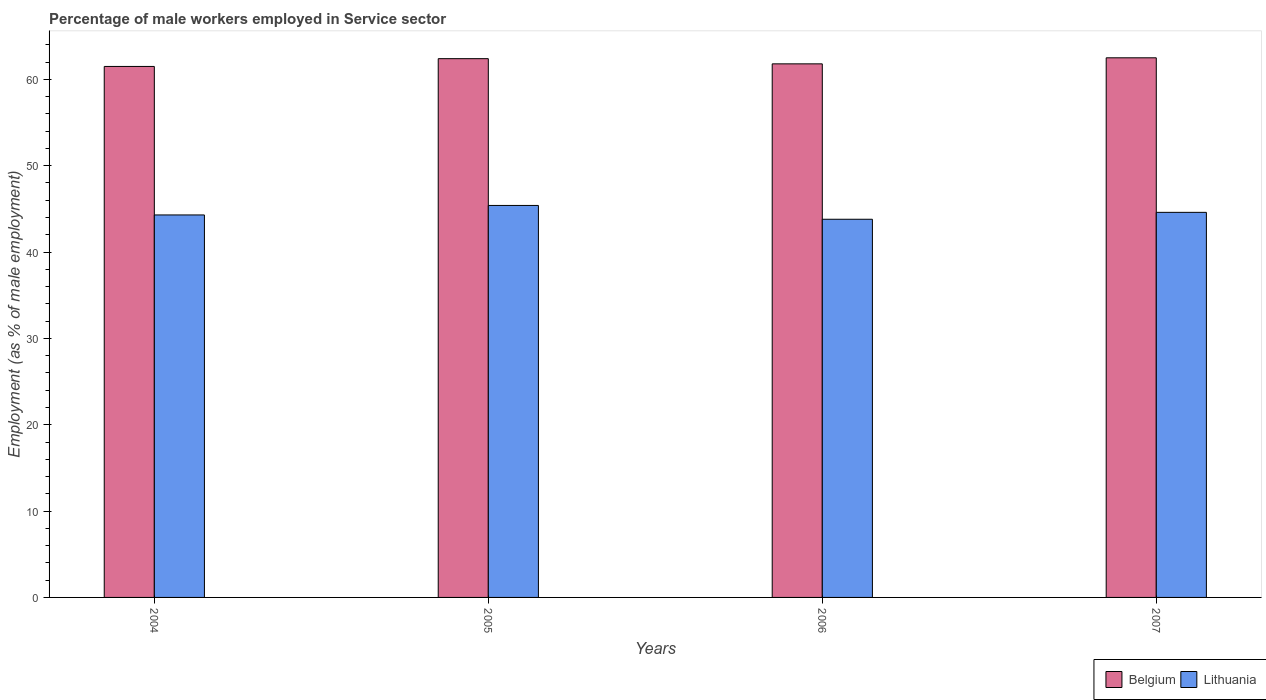How many different coloured bars are there?
Offer a very short reply. 2. How many groups of bars are there?
Give a very brief answer. 4. Are the number of bars per tick equal to the number of legend labels?
Provide a succinct answer. Yes. What is the label of the 2nd group of bars from the left?
Offer a terse response. 2005. In how many cases, is the number of bars for a given year not equal to the number of legend labels?
Ensure brevity in your answer.  0. What is the percentage of male workers employed in Service sector in Belgium in 2006?
Offer a terse response. 61.8. Across all years, what is the maximum percentage of male workers employed in Service sector in Belgium?
Make the answer very short. 62.5. Across all years, what is the minimum percentage of male workers employed in Service sector in Belgium?
Offer a very short reply. 61.5. In which year was the percentage of male workers employed in Service sector in Belgium maximum?
Give a very brief answer. 2007. What is the total percentage of male workers employed in Service sector in Belgium in the graph?
Your answer should be very brief. 248.2. What is the difference between the percentage of male workers employed in Service sector in Belgium in 2004 and that in 2005?
Give a very brief answer. -0.9. What is the difference between the percentage of male workers employed in Service sector in Belgium in 2007 and the percentage of male workers employed in Service sector in Lithuania in 2005?
Offer a terse response. 17.1. What is the average percentage of male workers employed in Service sector in Belgium per year?
Provide a short and direct response. 62.05. In the year 2004, what is the difference between the percentage of male workers employed in Service sector in Lithuania and percentage of male workers employed in Service sector in Belgium?
Make the answer very short. -17.2. What is the ratio of the percentage of male workers employed in Service sector in Belgium in 2005 to that in 2007?
Keep it short and to the point. 1. Is the difference between the percentage of male workers employed in Service sector in Lithuania in 2006 and 2007 greater than the difference between the percentage of male workers employed in Service sector in Belgium in 2006 and 2007?
Your answer should be compact. No. What is the difference between the highest and the second highest percentage of male workers employed in Service sector in Lithuania?
Give a very brief answer. 0.8. What is the difference between the highest and the lowest percentage of male workers employed in Service sector in Lithuania?
Provide a succinct answer. 1.6. In how many years, is the percentage of male workers employed in Service sector in Belgium greater than the average percentage of male workers employed in Service sector in Belgium taken over all years?
Keep it short and to the point. 2. What does the 1st bar from the right in 2006 represents?
Keep it short and to the point. Lithuania. How many bars are there?
Offer a very short reply. 8. Are all the bars in the graph horizontal?
Your answer should be compact. No. How many years are there in the graph?
Give a very brief answer. 4. Are the values on the major ticks of Y-axis written in scientific E-notation?
Provide a succinct answer. No. Does the graph contain grids?
Provide a short and direct response. No. How are the legend labels stacked?
Keep it short and to the point. Horizontal. What is the title of the graph?
Your answer should be very brief. Percentage of male workers employed in Service sector. What is the label or title of the X-axis?
Ensure brevity in your answer.  Years. What is the label or title of the Y-axis?
Provide a short and direct response. Employment (as % of male employment). What is the Employment (as % of male employment) in Belgium in 2004?
Your answer should be compact. 61.5. What is the Employment (as % of male employment) of Lithuania in 2004?
Offer a very short reply. 44.3. What is the Employment (as % of male employment) in Belgium in 2005?
Ensure brevity in your answer.  62.4. What is the Employment (as % of male employment) in Lithuania in 2005?
Your answer should be very brief. 45.4. What is the Employment (as % of male employment) of Belgium in 2006?
Provide a succinct answer. 61.8. What is the Employment (as % of male employment) in Lithuania in 2006?
Your answer should be very brief. 43.8. What is the Employment (as % of male employment) in Belgium in 2007?
Make the answer very short. 62.5. What is the Employment (as % of male employment) in Lithuania in 2007?
Your answer should be compact. 44.6. Across all years, what is the maximum Employment (as % of male employment) of Belgium?
Provide a succinct answer. 62.5. Across all years, what is the maximum Employment (as % of male employment) of Lithuania?
Your response must be concise. 45.4. Across all years, what is the minimum Employment (as % of male employment) of Belgium?
Offer a terse response. 61.5. Across all years, what is the minimum Employment (as % of male employment) of Lithuania?
Make the answer very short. 43.8. What is the total Employment (as % of male employment) of Belgium in the graph?
Provide a succinct answer. 248.2. What is the total Employment (as % of male employment) in Lithuania in the graph?
Give a very brief answer. 178.1. What is the difference between the Employment (as % of male employment) of Lithuania in 2004 and that in 2005?
Offer a very short reply. -1.1. What is the difference between the Employment (as % of male employment) in Belgium in 2004 and that in 2006?
Provide a short and direct response. -0.3. What is the difference between the Employment (as % of male employment) in Belgium in 2004 and that in 2007?
Your answer should be very brief. -1. What is the difference between the Employment (as % of male employment) in Belgium in 2005 and that in 2006?
Provide a succinct answer. 0.6. What is the difference between the Employment (as % of male employment) in Lithuania in 2005 and that in 2006?
Your response must be concise. 1.6. What is the difference between the Employment (as % of male employment) of Belgium in 2005 and that in 2007?
Your answer should be very brief. -0.1. What is the difference between the Employment (as % of male employment) of Belgium in 2005 and the Employment (as % of male employment) of Lithuania in 2007?
Offer a very short reply. 17.8. What is the average Employment (as % of male employment) of Belgium per year?
Your response must be concise. 62.05. What is the average Employment (as % of male employment) in Lithuania per year?
Provide a succinct answer. 44.52. In the year 2006, what is the difference between the Employment (as % of male employment) of Belgium and Employment (as % of male employment) of Lithuania?
Make the answer very short. 18. What is the ratio of the Employment (as % of male employment) of Belgium in 2004 to that in 2005?
Keep it short and to the point. 0.99. What is the ratio of the Employment (as % of male employment) in Lithuania in 2004 to that in 2005?
Provide a succinct answer. 0.98. What is the ratio of the Employment (as % of male employment) of Lithuania in 2004 to that in 2006?
Your answer should be compact. 1.01. What is the ratio of the Employment (as % of male employment) in Belgium in 2004 to that in 2007?
Your response must be concise. 0.98. What is the ratio of the Employment (as % of male employment) of Belgium in 2005 to that in 2006?
Provide a succinct answer. 1.01. What is the ratio of the Employment (as % of male employment) of Lithuania in 2005 to that in 2006?
Provide a succinct answer. 1.04. What is the ratio of the Employment (as % of male employment) in Belgium in 2005 to that in 2007?
Offer a very short reply. 1. What is the ratio of the Employment (as % of male employment) in Lithuania in 2005 to that in 2007?
Your answer should be compact. 1.02. What is the ratio of the Employment (as % of male employment) in Belgium in 2006 to that in 2007?
Your answer should be very brief. 0.99. What is the ratio of the Employment (as % of male employment) of Lithuania in 2006 to that in 2007?
Offer a terse response. 0.98. What is the difference between the highest and the second highest Employment (as % of male employment) in Lithuania?
Offer a terse response. 0.8. 